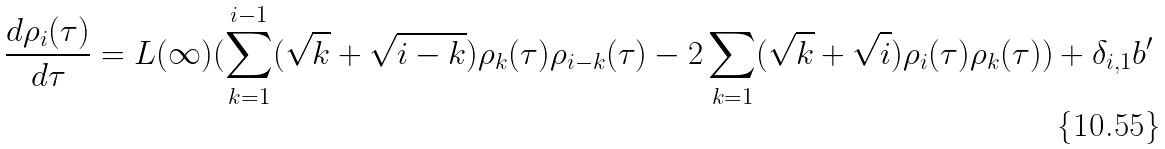<formula> <loc_0><loc_0><loc_500><loc_500>\frac { d \rho _ { i } ( \tau ) } { d \tau } = L ( \infty ) ( \sum _ { k = 1 } ^ { i - 1 } ( \sqrt { k } + \sqrt { i - k } ) \rho _ { k } ( \tau ) \rho _ { i - k } ( \tau ) - 2 \sum _ { k = 1 } ( \sqrt { k } + \sqrt { i } ) \rho _ { i } ( \tau ) \rho _ { k } ( \tau ) ) + \delta _ { i , 1 } b ^ { \prime }</formula> 